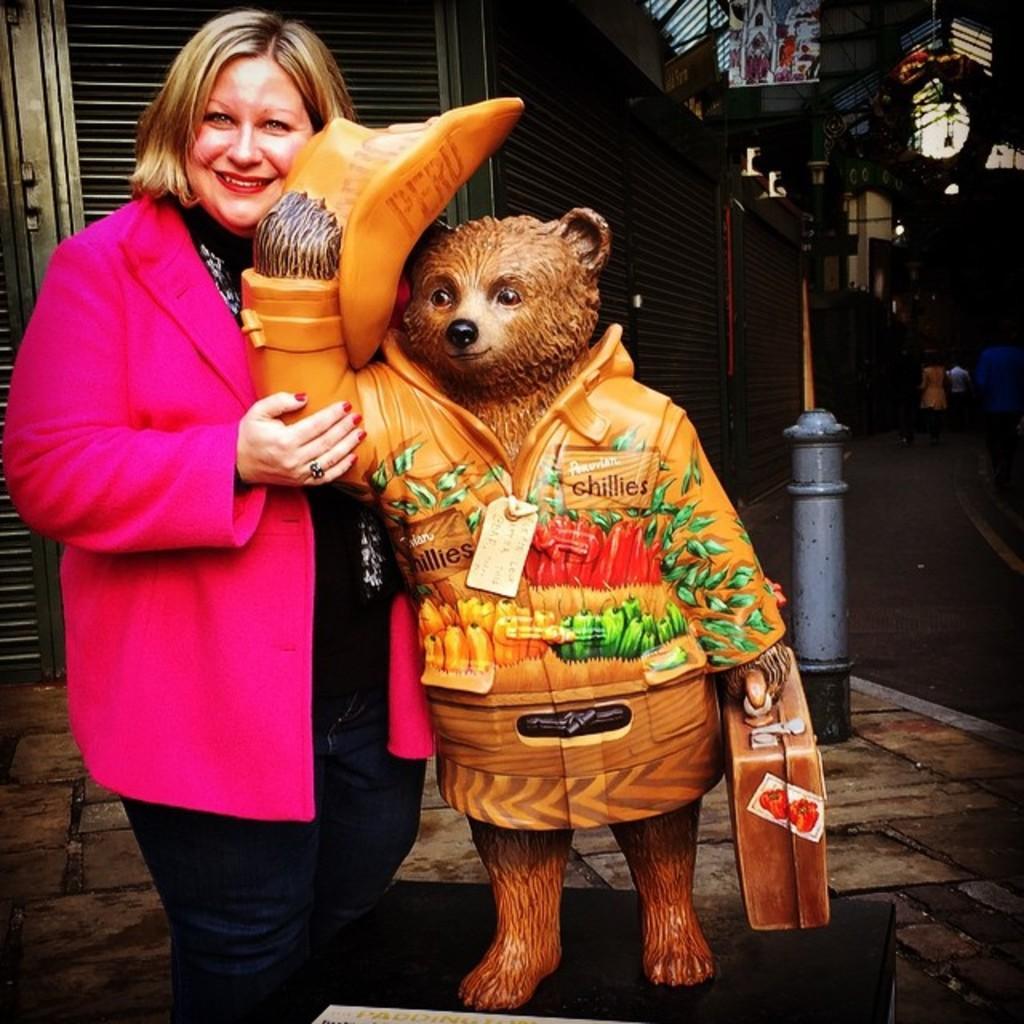Can you describe this image briefly? In this image I can see an animal statue and the statue is in brown color and I can also see the person standing and the person is wearing pink and black color dress. In the background I can see few rolling shutters. 